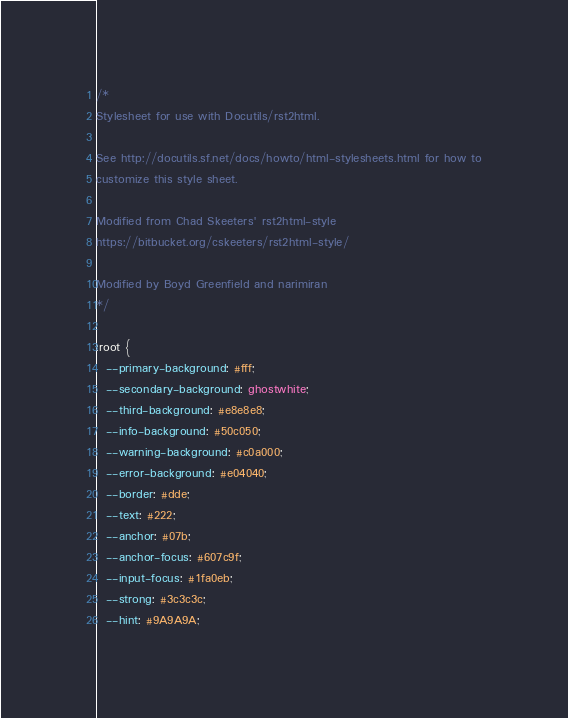Convert code to text. <code><loc_0><loc_0><loc_500><loc_500><_CSS_>/*
Stylesheet for use with Docutils/rst2html.

See http://docutils.sf.net/docs/howto/html-stylesheets.html for how to
customize this style sheet.

Modified from Chad Skeeters' rst2html-style
https://bitbucket.org/cskeeters/rst2html-style/

Modified by Boyd Greenfield and narimiran
*/

:root {
  --primary-background: #fff;
  --secondary-background: ghostwhite;
  --third-background: #e8e8e8;
  --info-background: #50c050;
  --warning-background: #c0a000;
  --error-background: #e04040;
  --border: #dde;
  --text: #222;
  --anchor: #07b;
  --anchor-focus: #607c9f;
  --input-focus: #1fa0eb;
  --strong: #3c3c3c;
  --hint: #9A9A9A;</code> 